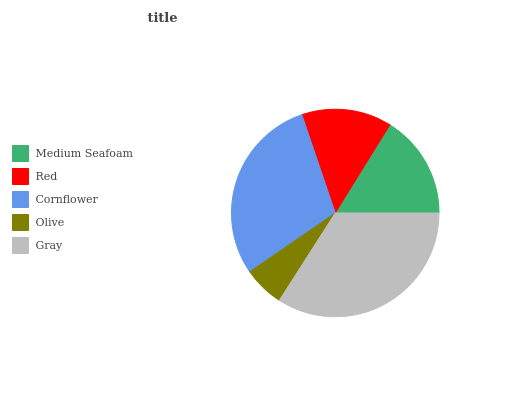Is Olive the minimum?
Answer yes or no. Yes. Is Gray the maximum?
Answer yes or no. Yes. Is Red the minimum?
Answer yes or no. No. Is Red the maximum?
Answer yes or no. No. Is Medium Seafoam greater than Red?
Answer yes or no. Yes. Is Red less than Medium Seafoam?
Answer yes or no. Yes. Is Red greater than Medium Seafoam?
Answer yes or no. No. Is Medium Seafoam less than Red?
Answer yes or no. No. Is Medium Seafoam the high median?
Answer yes or no. Yes. Is Medium Seafoam the low median?
Answer yes or no. Yes. Is Cornflower the high median?
Answer yes or no. No. Is Olive the low median?
Answer yes or no. No. 